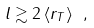<formula> <loc_0><loc_0><loc_500><loc_500>l \gtrsim 2 \, \langle r _ { T } \rangle \ ,</formula> 